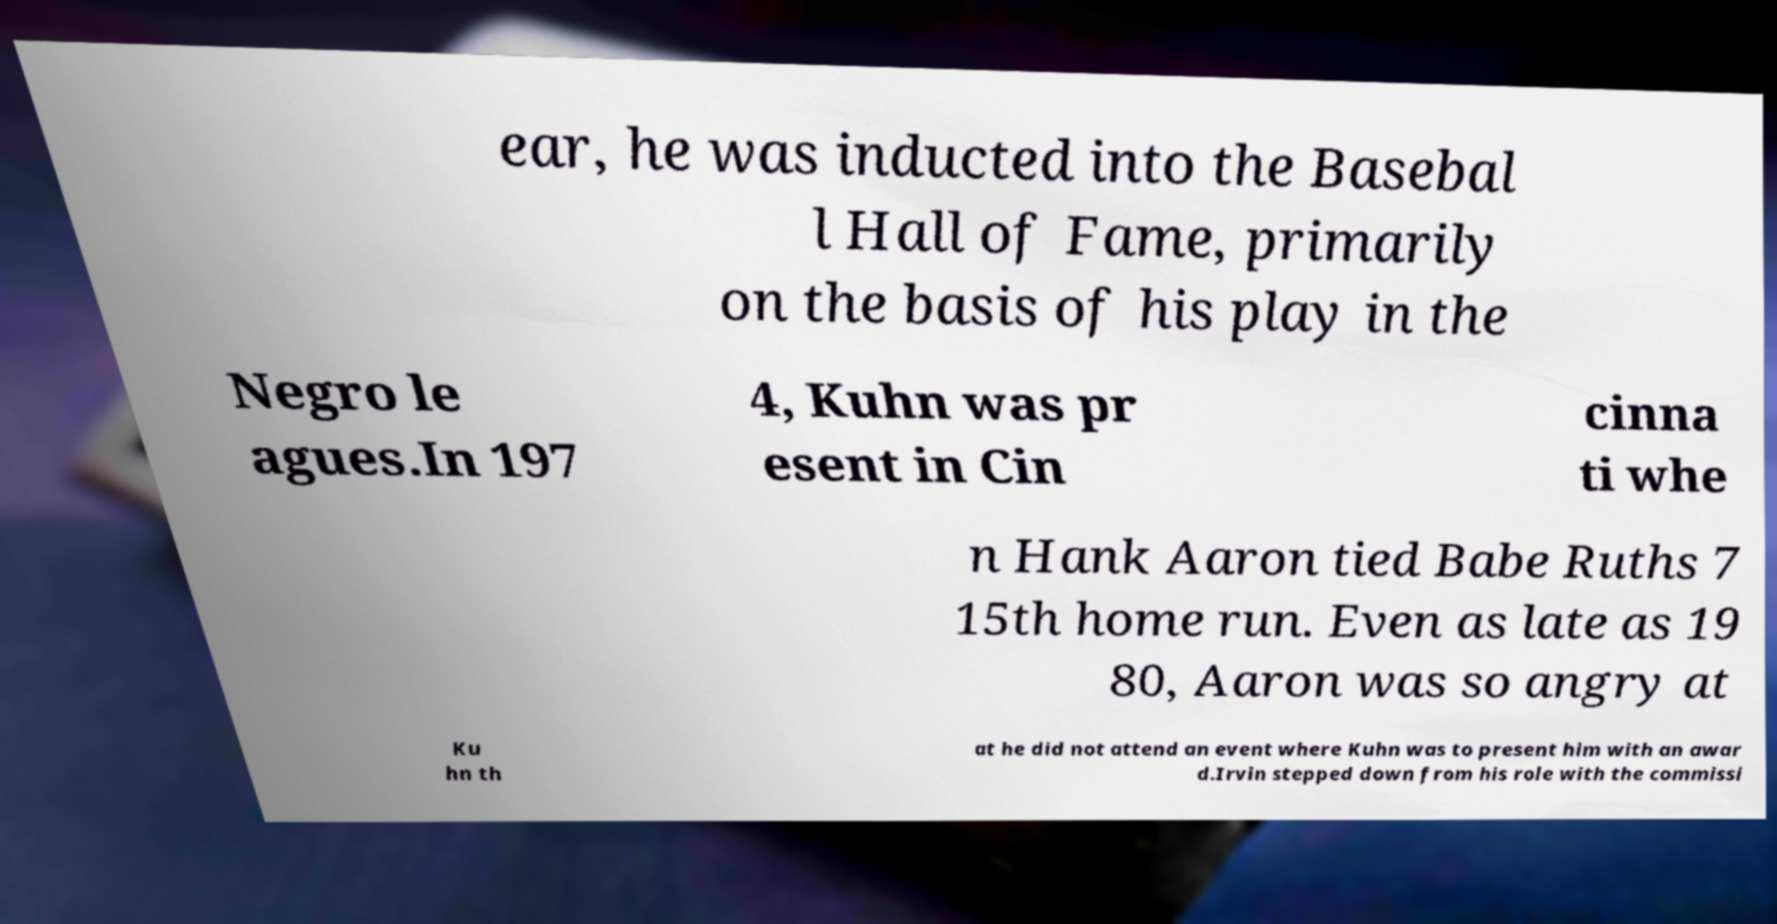Can you read and provide the text displayed in the image?This photo seems to have some interesting text. Can you extract and type it out for me? ear, he was inducted into the Basebal l Hall of Fame, primarily on the basis of his play in the Negro le agues.In 197 4, Kuhn was pr esent in Cin cinna ti whe n Hank Aaron tied Babe Ruths 7 15th home run. Even as late as 19 80, Aaron was so angry at Ku hn th at he did not attend an event where Kuhn was to present him with an awar d.Irvin stepped down from his role with the commissi 